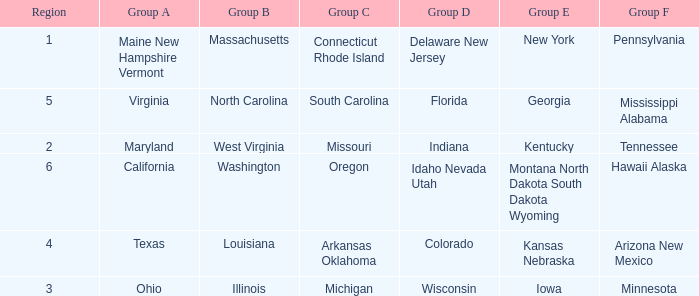Help me parse the entirety of this table. {'header': ['Region', 'Group A', 'Group B', 'Group C', 'Group D', 'Group E', 'Group F'], 'rows': [['1', 'Maine New Hampshire Vermont', 'Massachusetts', 'Connecticut Rhode Island', 'Delaware New Jersey', 'New York', 'Pennsylvania'], ['5', 'Virginia', 'North Carolina', 'South Carolina', 'Florida', 'Georgia', 'Mississippi Alabama'], ['2', 'Maryland', 'West Virginia', 'Missouri', 'Indiana', 'Kentucky', 'Tennessee'], ['6', 'California', 'Washington', 'Oregon', 'Idaho Nevada Utah', 'Montana North Dakota South Dakota Wyoming', 'Hawaii Alaska'], ['4', 'Texas', 'Louisiana', 'Arkansas Oklahoma', 'Colorado', 'Kansas Nebraska', 'Arizona New Mexico'], ['3', 'Ohio', 'Illinois', 'Michigan', 'Wisconsin', 'Iowa', 'Minnesota']]} What is the group B region with a Group E region of Georgia? North Carolina. 